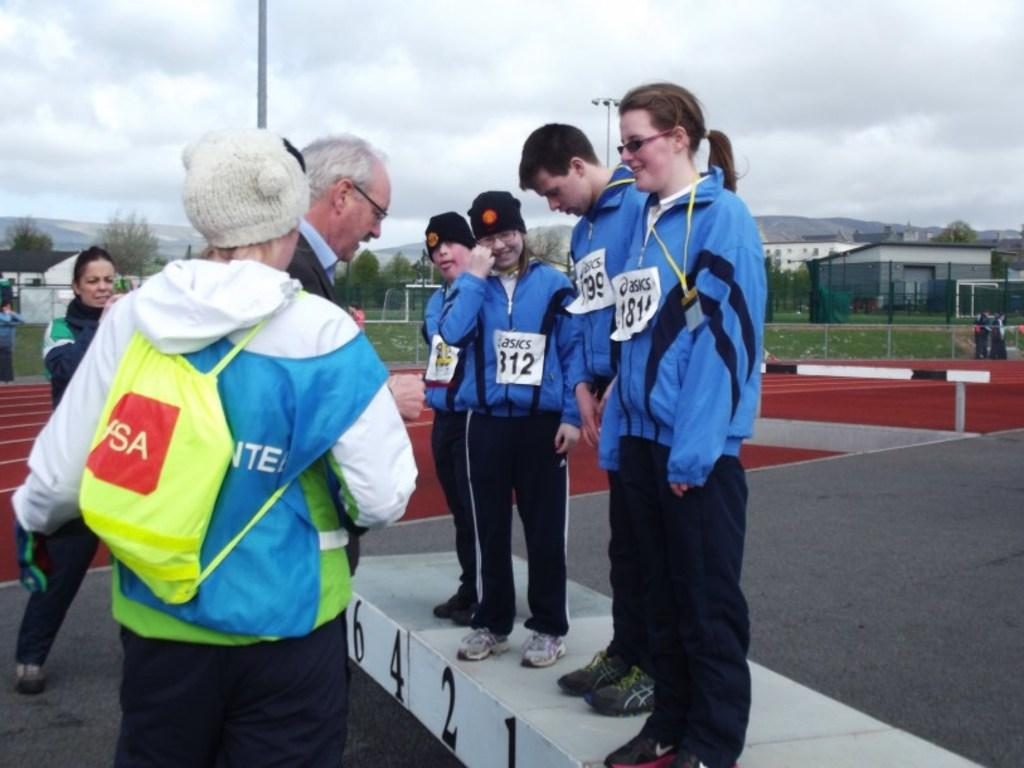Provide a one-sentence caption for the provided image. Four people in blue jackets are standing on a podium with name tags from asics. 